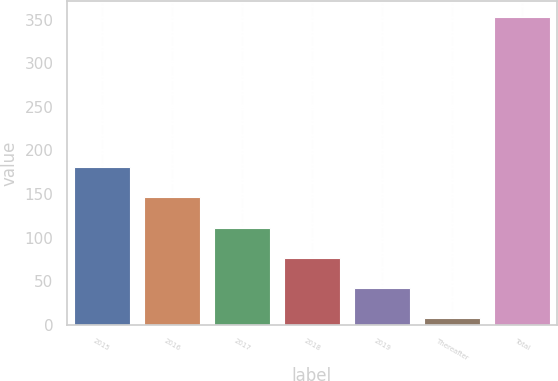Convert chart. <chart><loc_0><loc_0><loc_500><loc_500><bar_chart><fcel>2015<fcel>2016<fcel>2017<fcel>2018<fcel>2019<fcel>Thereafter<fcel>Total<nl><fcel>180.7<fcel>146.1<fcel>111.5<fcel>76.9<fcel>42.3<fcel>7.7<fcel>353.7<nl></chart> 